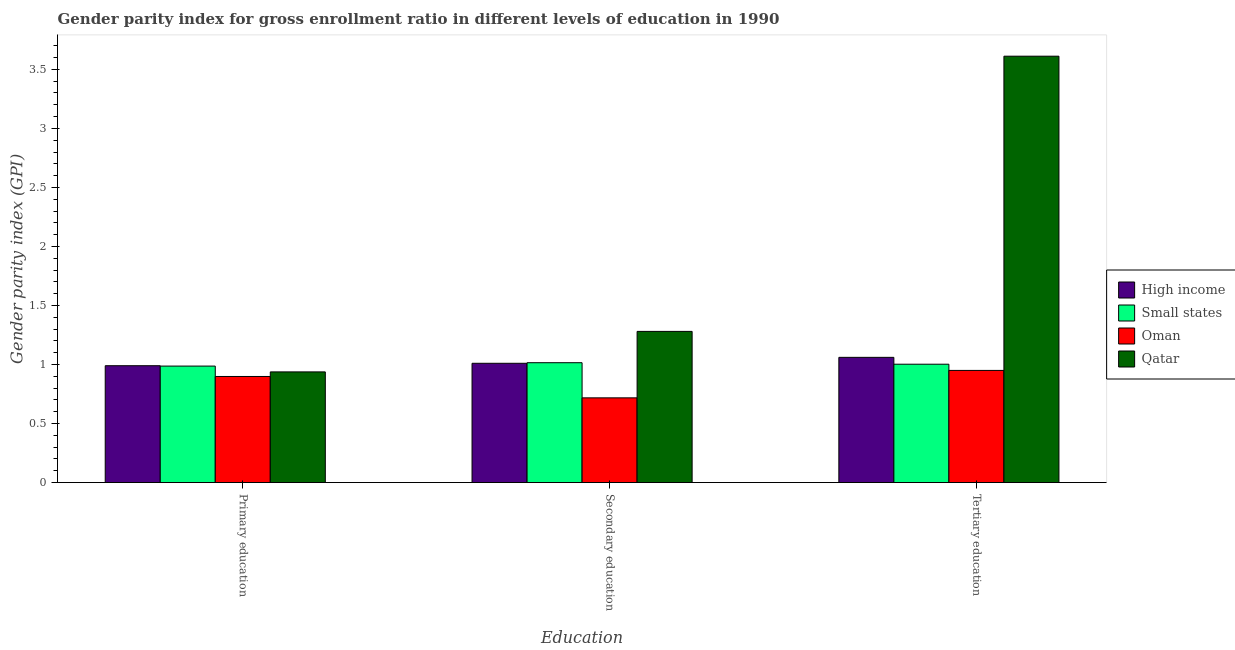How many different coloured bars are there?
Give a very brief answer. 4. What is the label of the 2nd group of bars from the left?
Provide a short and direct response. Secondary education. What is the gender parity index in primary education in High income?
Make the answer very short. 0.99. Across all countries, what is the maximum gender parity index in primary education?
Provide a short and direct response. 0.99. Across all countries, what is the minimum gender parity index in primary education?
Offer a very short reply. 0.9. In which country was the gender parity index in tertiary education maximum?
Offer a terse response. Qatar. In which country was the gender parity index in primary education minimum?
Your answer should be very brief. Oman. What is the total gender parity index in tertiary education in the graph?
Your answer should be compact. 6.63. What is the difference between the gender parity index in tertiary education in Small states and that in Qatar?
Offer a very short reply. -2.61. What is the difference between the gender parity index in tertiary education in Qatar and the gender parity index in primary education in High income?
Your answer should be very brief. 2.62. What is the average gender parity index in secondary education per country?
Keep it short and to the point. 1.01. What is the difference between the gender parity index in tertiary education and gender parity index in primary education in Small states?
Your answer should be very brief. 0.02. What is the ratio of the gender parity index in tertiary education in Small states to that in High income?
Offer a terse response. 0.95. What is the difference between the highest and the second highest gender parity index in primary education?
Offer a terse response. 0. What is the difference between the highest and the lowest gender parity index in tertiary education?
Keep it short and to the point. 2.66. In how many countries, is the gender parity index in tertiary education greater than the average gender parity index in tertiary education taken over all countries?
Keep it short and to the point. 1. What does the 4th bar from the left in Secondary education represents?
Offer a very short reply. Qatar. How many countries are there in the graph?
Provide a succinct answer. 4. Are the values on the major ticks of Y-axis written in scientific E-notation?
Ensure brevity in your answer.  No. Does the graph contain any zero values?
Your response must be concise. No. Does the graph contain grids?
Your answer should be compact. No. How many legend labels are there?
Provide a short and direct response. 4. How are the legend labels stacked?
Provide a short and direct response. Vertical. What is the title of the graph?
Keep it short and to the point. Gender parity index for gross enrollment ratio in different levels of education in 1990. What is the label or title of the X-axis?
Provide a succinct answer. Education. What is the label or title of the Y-axis?
Your answer should be compact. Gender parity index (GPI). What is the Gender parity index (GPI) of High income in Primary education?
Your response must be concise. 0.99. What is the Gender parity index (GPI) in Small states in Primary education?
Your answer should be very brief. 0.99. What is the Gender parity index (GPI) of Oman in Primary education?
Provide a short and direct response. 0.9. What is the Gender parity index (GPI) in Qatar in Primary education?
Provide a succinct answer. 0.94. What is the Gender parity index (GPI) in High income in Secondary education?
Your answer should be compact. 1.01. What is the Gender parity index (GPI) in Small states in Secondary education?
Make the answer very short. 1.02. What is the Gender parity index (GPI) in Oman in Secondary education?
Make the answer very short. 0.72. What is the Gender parity index (GPI) in Qatar in Secondary education?
Offer a terse response. 1.28. What is the Gender parity index (GPI) in High income in Tertiary education?
Ensure brevity in your answer.  1.06. What is the Gender parity index (GPI) in Small states in Tertiary education?
Ensure brevity in your answer.  1. What is the Gender parity index (GPI) of Oman in Tertiary education?
Give a very brief answer. 0.95. What is the Gender parity index (GPI) in Qatar in Tertiary education?
Provide a succinct answer. 3.61. Across all Education, what is the maximum Gender parity index (GPI) in High income?
Your answer should be compact. 1.06. Across all Education, what is the maximum Gender parity index (GPI) in Small states?
Give a very brief answer. 1.02. Across all Education, what is the maximum Gender parity index (GPI) in Oman?
Ensure brevity in your answer.  0.95. Across all Education, what is the maximum Gender parity index (GPI) in Qatar?
Your answer should be very brief. 3.61. Across all Education, what is the minimum Gender parity index (GPI) in High income?
Provide a succinct answer. 0.99. Across all Education, what is the minimum Gender parity index (GPI) of Small states?
Ensure brevity in your answer.  0.99. Across all Education, what is the minimum Gender parity index (GPI) in Oman?
Make the answer very short. 0.72. Across all Education, what is the minimum Gender parity index (GPI) in Qatar?
Provide a succinct answer. 0.94. What is the total Gender parity index (GPI) of High income in the graph?
Ensure brevity in your answer.  3.06. What is the total Gender parity index (GPI) of Small states in the graph?
Give a very brief answer. 3.01. What is the total Gender parity index (GPI) of Oman in the graph?
Keep it short and to the point. 2.57. What is the total Gender parity index (GPI) in Qatar in the graph?
Keep it short and to the point. 5.83. What is the difference between the Gender parity index (GPI) of High income in Primary education and that in Secondary education?
Provide a short and direct response. -0.02. What is the difference between the Gender parity index (GPI) in Small states in Primary education and that in Secondary education?
Ensure brevity in your answer.  -0.03. What is the difference between the Gender parity index (GPI) in Oman in Primary education and that in Secondary education?
Give a very brief answer. 0.18. What is the difference between the Gender parity index (GPI) of Qatar in Primary education and that in Secondary education?
Offer a terse response. -0.34. What is the difference between the Gender parity index (GPI) of High income in Primary education and that in Tertiary education?
Your answer should be very brief. -0.07. What is the difference between the Gender parity index (GPI) in Small states in Primary education and that in Tertiary education?
Offer a terse response. -0.02. What is the difference between the Gender parity index (GPI) in Oman in Primary education and that in Tertiary education?
Offer a very short reply. -0.05. What is the difference between the Gender parity index (GPI) of Qatar in Primary education and that in Tertiary education?
Offer a terse response. -2.67. What is the difference between the Gender parity index (GPI) of High income in Secondary education and that in Tertiary education?
Offer a terse response. -0.05. What is the difference between the Gender parity index (GPI) of Small states in Secondary education and that in Tertiary education?
Offer a very short reply. 0.01. What is the difference between the Gender parity index (GPI) in Oman in Secondary education and that in Tertiary education?
Give a very brief answer. -0.23. What is the difference between the Gender parity index (GPI) of Qatar in Secondary education and that in Tertiary education?
Ensure brevity in your answer.  -2.33. What is the difference between the Gender parity index (GPI) of High income in Primary education and the Gender parity index (GPI) of Small states in Secondary education?
Your response must be concise. -0.03. What is the difference between the Gender parity index (GPI) of High income in Primary education and the Gender parity index (GPI) of Oman in Secondary education?
Provide a short and direct response. 0.27. What is the difference between the Gender parity index (GPI) in High income in Primary education and the Gender parity index (GPI) in Qatar in Secondary education?
Your answer should be very brief. -0.29. What is the difference between the Gender parity index (GPI) in Small states in Primary education and the Gender parity index (GPI) in Oman in Secondary education?
Offer a very short reply. 0.27. What is the difference between the Gender parity index (GPI) of Small states in Primary education and the Gender parity index (GPI) of Qatar in Secondary education?
Ensure brevity in your answer.  -0.29. What is the difference between the Gender parity index (GPI) in Oman in Primary education and the Gender parity index (GPI) in Qatar in Secondary education?
Provide a short and direct response. -0.38. What is the difference between the Gender parity index (GPI) of High income in Primary education and the Gender parity index (GPI) of Small states in Tertiary education?
Make the answer very short. -0.01. What is the difference between the Gender parity index (GPI) in High income in Primary education and the Gender parity index (GPI) in Oman in Tertiary education?
Make the answer very short. 0.04. What is the difference between the Gender parity index (GPI) of High income in Primary education and the Gender parity index (GPI) of Qatar in Tertiary education?
Offer a terse response. -2.62. What is the difference between the Gender parity index (GPI) in Small states in Primary education and the Gender parity index (GPI) in Oman in Tertiary education?
Ensure brevity in your answer.  0.04. What is the difference between the Gender parity index (GPI) of Small states in Primary education and the Gender parity index (GPI) of Qatar in Tertiary education?
Provide a short and direct response. -2.62. What is the difference between the Gender parity index (GPI) of Oman in Primary education and the Gender parity index (GPI) of Qatar in Tertiary education?
Make the answer very short. -2.71. What is the difference between the Gender parity index (GPI) in High income in Secondary education and the Gender parity index (GPI) in Small states in Tertiary education?
Offer a terse response. 0.01. What is the difference between the Gender parity index (GPI) of High income in Secondary education and the Gender parity index (GPI) of Oman in Tertiary education?
Keep it short and to the point. 0.06. What is the difference between the Gender parity index (GPI) in High income in Secondary education and the Gender parity index (GPI) in Qatar in Tertiary education?
Provide a short and direct response. -2.6. What is the difference between the Gender parity index (GPI) of Small states in Secondary education and the Gender parity index (GPI) of Oman in Tertiary education?
Your answer should be compact. 0.07. What is the difference between the Gender parity index (GPI) of Small states in Secondary education and the Gender parity index (GPI) of Qatar in Tertiary education?
Your response must be concise. -2.6. What is the difference between the Gender parity index (GPI) of Oman in Secondary education and the Gender parity index (GPI) of Qatar in Tertiary education?
Ensure brevity in your answer.  -2.89. What is the average Gender parity index (GPI) of High income per Education?
Your answer should be compact. 1.02. What is the average Gender parity index (GPI) in Small states per Education?
Provide a succinct answer. 1. What is the average Gender parity index (GPI) in Oman per Education?
Your answer should be very brief. 0.86. What is the average Gender parity index (GPI) in Qatar per Education?
Make the answer very short. 1.94. What is the difference between the Gender parity index (GPI) in High income and Gender parity index (GPI) in Small states in Primary education?
Ensure brevity in your answer.  0. What is the difference between the Gender parity index (GPI) of High income and Gender parity index (GPI) of Oman in Primary education?
Your response must be concise. 0.09. What is the difference between the Gender parity index (GPI) in High income and Gender parity index (GPI) in Qatar in Primary education?
Your response must be concise. 0.05. What is the difference between the Gender parity index (GPI) in Small states and Gender parity index (GPI) in Oman in Primary education?
Keep it short and to the point. 0.09. What is the difference between the Gender parity index (GPI) in Small states and Gender parity index (GPI) in Qatar in Primary education?
Give a very brief answer. 0.05. What is the difference between the Gender parity index (GPI) of Oman and Gender parity index (GPI) of Qatar in Primary education?
Your answer should be very brief. -0.04. What is the difference between the Gender parity index (GPI) in High income and Gender parity index (GPI) in Small states in Secondary education?
Offer a terse response. -0. What is the difference between the Gender parity index (GPI) in High income and Gender parity index (GPI) in Oman in Secondary education?
Offer a very short reply. 0.29. What is the difference between the Gender parity index (GPI) of High income and Gender parity index (GPI) of Qatar in Secondary education?
Your answer should be very brief. -0.27. What is the difference between the Gender parity index (GPI) of Small states and Gender parity index (GPI) of Oman in Secondary education?
Keep it short and to the point. 0.3. What is the difference between the Gender parity index (GPI) in Small states and Gender parity index (GPI) in Qatar in Secondary education?
Your response must be concise. -0.27. What is the difference between the Gender parity index (GPI) of Oman and Gender parity index (GPI) of Qatar in Secondary education?
Give a very brief answer. -0.56. What is the difference between the Gender parity index (GPI) in High income and Gender parity index (GPI) in Small states in Tertiary education?
Give a very brief answer. 0.06. What is the difference between the Gender parity index (GPI) of High income and Gender parity index (GPI) of Oman in Tertiary education?
Your answer should be compact. 0.11. What is the difference between the Gender parity index (GPI) of High income and Gender parity index (GPI) of Qatar in Tertiary education?
Provide a short and direct response. -2.55. What is the difference between the Gender parity index (GPI) in Small states and Gender parity index (GPI) in Oman in Tertiary education?
Your response must be concise. 0.05. What is the difference between the Gender parity index (GPI) in Small states and Gender parity index (GPI) in Qatar in Tertiary education?
Give a very brief answer. -2.61. What is the difference between the Gender parity index (GPI) in Oman and Gender parity index (GPI) in Qatar in Tertiary education?
Give a very brief answer. -2.66. What is the ratio of the Gender parity index (GPI) of High income in Primary education to that in Secondary education?
Give a very brief answer. 0.98. What is the ratio of the Gender parity index (GPI) in Small states in Primary education to that in Secondary education?
Your answer should be compact. 0.97. What is the ratio of the Gender parity index (GPI) of Oman in Primary education to that in Secondary education?
Your answer should be compact. 1.25. What is the ratio of the Gender parity index (GPI) in Qatar in Primary education to that in Secondary education?
Provide a succinct answer. 0.73. What is the ratio of the Gender parity index (GPI) in High income in Primary education to that in Tertiary education?
Provide a succinct answer. 0.93. What is the ratio of the Gender parity index (GPI) of Small states in Primary education to that in Tertiary education?
Ensure brevity in your answer.  0.98. What is the ratio of the Gender parity index (GPI) in Oman in Primary education to that in Tertiary education?
Your answer should be very brief. 0.95. What is the ratio of the Gender parity index (GPI) of Qatar in Primary education to that in Tertiary education?
Your answer should be very brief. 0.26. What is the ratio of the Gender parity index (GPI) of High income in Secondary education to that in Tertiary education?
Ensure brevity in your answer.  0.95. What is the ratio of the Gender parity index (GPI) in Small states in Secondary education to that in Tertiary education?
Your response must be concise. 1.01. What is the ratio of the Gender parity index (GPI) in Oman in Secondary education to that in Tertiary education?
Offer a terse response. 0.76. What is the ratio of the Gender parity index (GPI) of Qatar in Secondary education to that in Tertiary education?
Give a very brief answer. 0.35. What is the difference between the highest and the second highest Gender parity index (GPI) of High income?
Your answer should be very brief. 0.05. What is the difference between the highest and the second highest Gender parity index (GPI) in Small states?
Your answer should be very brief. 0.01. What is the difference between the highest and the second highest Gender parity index (GPI) in Oman?
Provide a succinct answer. 0.05. What is the difference between the highest and the second highest Gender parity index (GPI) in Qatar?
Offer a very short reply. 2.33. What is the difference between the highest and the lowest Gender parity index (GPI) in High income?
Offer a very short reply. 0.07. What is the difference between the highest and the lowest Gender parity index (GPI) in Small states?
Provide a succinct answer. 0.03. What is the difference between the highest and the lowest Gender parity index (GPI) of Oman?
Give a very brief answer. 0.23. What is the difference between the highest and the lowest Gender parity index (GPI) in Qatar?
Your answer should be very brief. 2.67. 